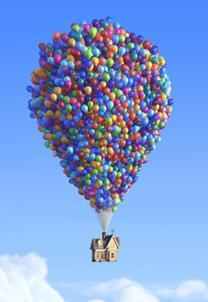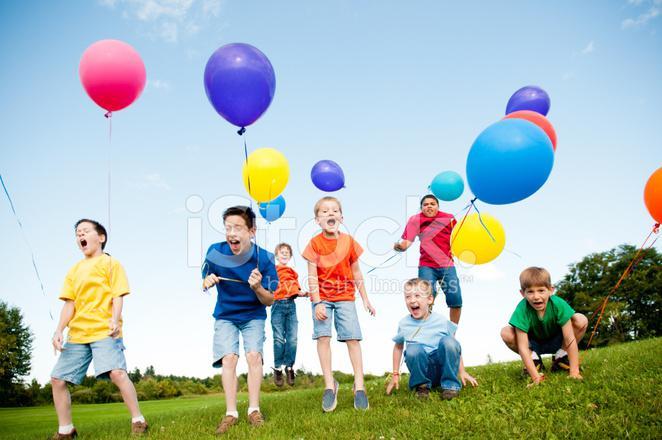The first image is the image on the left, the second image is the image on the right. Examine the images to the left and right. Is the description "There is at least one person holding balloons." accurate? Answer yes or no. Yes. The first image is the image on the left, the second image is the image on the right. Analyze the images presented: Is the assertion "Balloons are carrying an object up in the air." valid? Answer yes or no. Yes. 